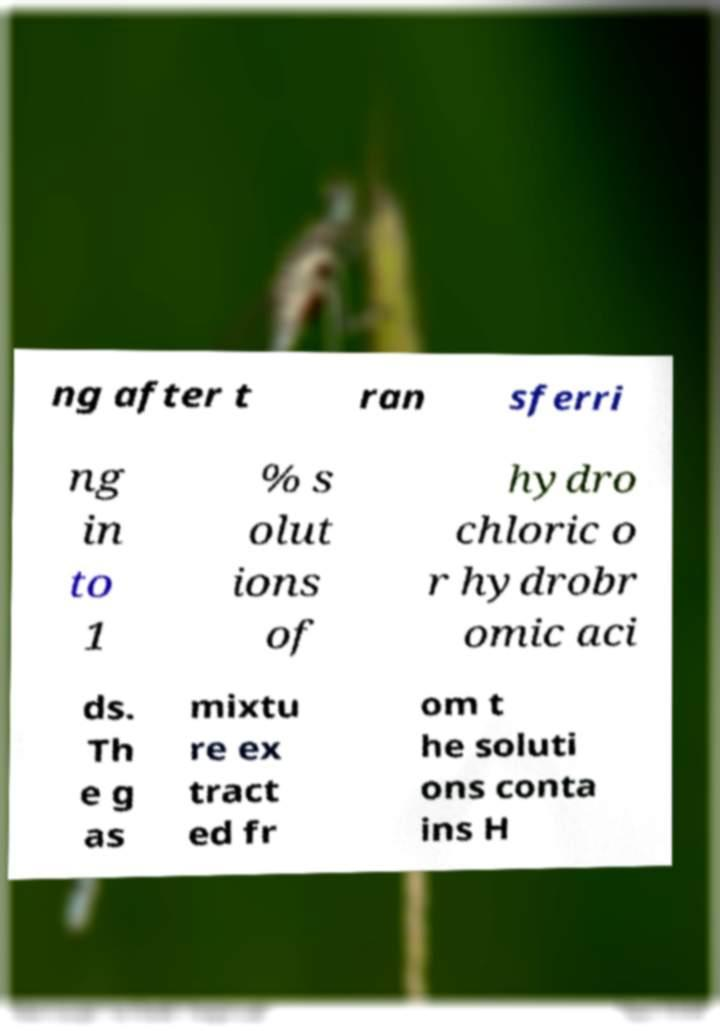What messages or text are displayed in this image? I need them in a readable, typed format. ng after t ran sferri ng in to 1 % s olut ions of hydro chloric o r hydrobr omic aci ds. Th e g as mixtu re ex tract ed fr om t he soluti ons conta ins H 